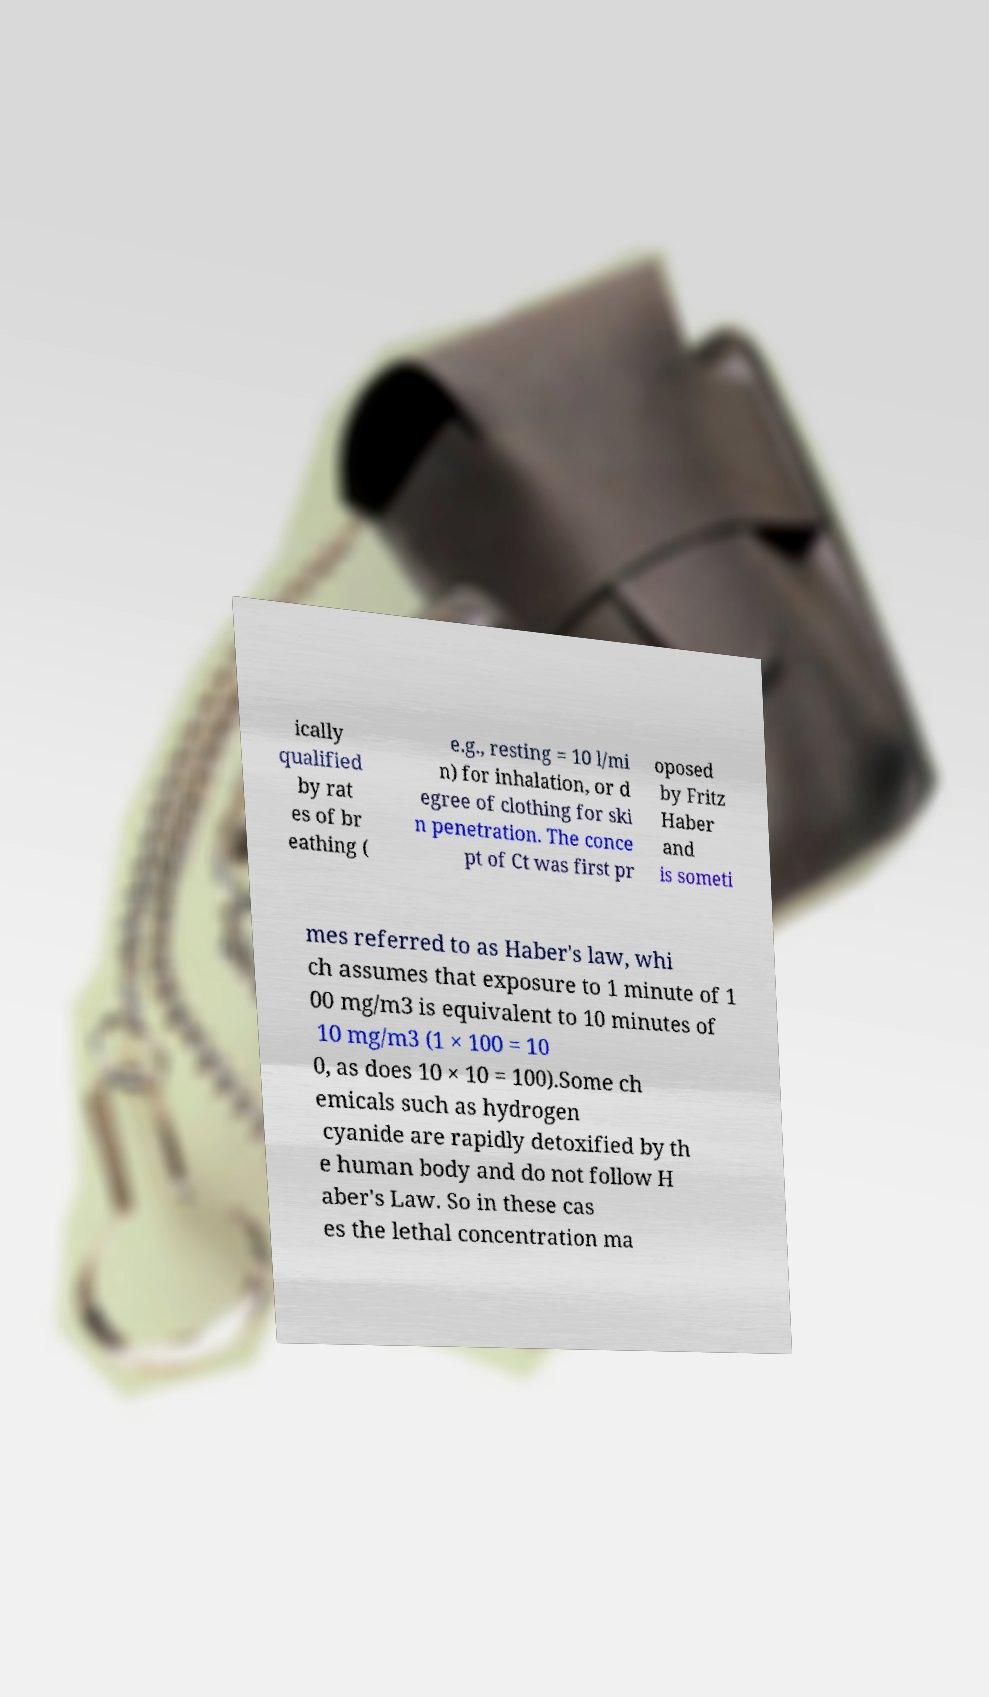Please identify and transcribe the text found in this image. ically qualified by rat es of br eathing ( e.g., resting = 10 l/mi n) for inhalation, or d egree of clothing for ski n penetration. The conce pt of Ct was first pr oposed by Fritz Haber and is someti mes referred to as Haber's law, whi ch assumes that exposure to 1 minute of 1 00 mg/m3 is equivalent to 10 minutes of 10 mg/m3 (1 × 100 = 10 0, as does 10 × 10 = 100).Some ch emicals such as hydrogen cyanide are rapidly detoxified by th e human body and do not follow H aber's Law. So in these cas es the lethal concentration ma 